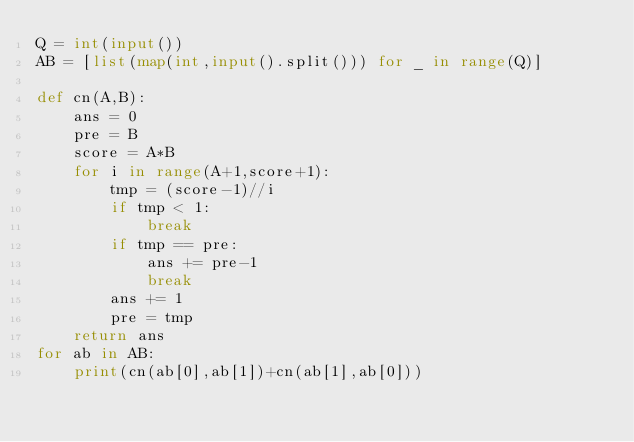Convert code to text. <code><loc_0><loc_0><loc_500><loc_500><_Python_>Q = int(input())
AB = [list(map(int,input().split())) for _ in range(Q)]

def cn(A,B):
    ans = 0
    pre = B
    score = A*B
    for i in range(A+1,score+1):
        tmp = (score-1)//i
        if tmp < 1:
            break
        if tmp == pre:
            ans += pre-1
            break
        ans += 1
        pre = tmp
    return ans
for ab in AB:
    print(cn(ab[0],ab[1])+cn(ab[1],ab[0]))
</code> 